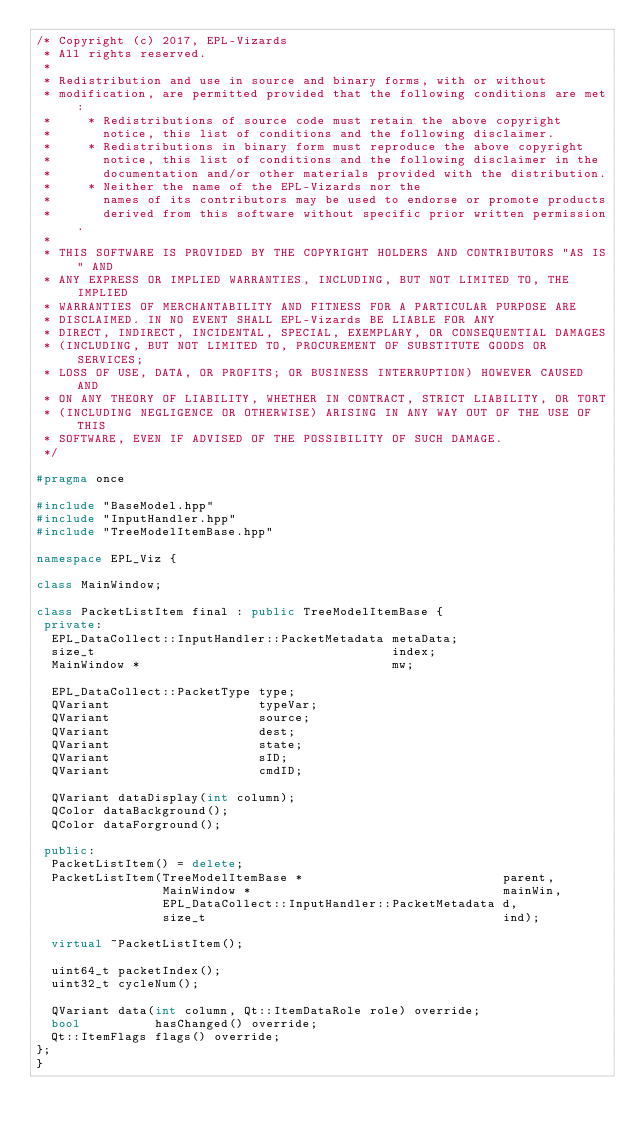Convert code to text. <code><loc_0><loc_0><loc_500><loc_500><_C++_>/* Copyright (c) 2017, EPL-Vizards
 * All rights reserved.
 *
 * Redistribution and use in source and binary forms, with or without
 * modification, are permitted provided that the following conditions are met:
 *     * Redistributions of source code must retain the above copyright
 *       notice, this list of conditions and the following disclaimer.
 *     * Redistributions in binary form must reproduce the above copyright
 *       notice, this list of conditions and the following disclaimer in the
 *       documentation and/or other materials provided with the distribution.
 *     * Neither the name of the EPL-Vizards nor the
 *       names of its contributors may be used to endorse or promote products
 *       derived from this software without specific prior written permission.
 *
 * THIS SOFTWARE IS PROVIDED BY THE COPYRIGHT HOLDERS AND CONTRIBUTORS "AS IS" AND
 * ANY EXPRESS OR IMPLIED WARRANTIES, INCLUDING, BUT NOT LIMITED TO, THE IMPLIED
 * WARRANTIES OF MERCHANTABILITY AND FITNESS FOR A PARTICULAR PURPOSE ARE
 * DISCLAIMED. IN NO EVENT SHALL EPL-Vizards BE LIABLE FOR ANY
 * DIRECT, INDIRECT, INCIDENTAL, SPECIAL, EXEMPLARY, OR CONSEQUENTIAL DAMAGES
 * (INCLUDING, BUT NOT LIMITED TO, PROCUREMENT OF SUBSTITUTE GOODS OR SERVICES;
 * LOSS OF USE, DATA, OR PROFITS; OR BUSINESS INTERRUPTION) HOWEVER CAUSED AND
 * ON ANY THEORY OF LIABILITY, WHETHER IN CONTRACT, STRICT LIABILITY, OR TORT
 * (INCLUDING NEGLIGENCE OR OTHERWISE) ARISING IN ANY WAY OUT OF THE USE OF THIS
 * SOFTWARE, EVEN IF ADVISED OF THE POSSIBILITY OF SUCH DAMAGE.
 */

#pragma once

#include "BaseModel.hpp"
#include "InputHandler.hpp"
#include "TreeModelItemBase.hpp"

namespace EPL_Viz {

class MainWindow;

class PacketListItem final : public TreeModelItemBase {
 private:
  EPL_DataCollect::InputHandler::PacketMetadata metaData;
  size_t                                        index;
  MainWindow *                                  mw;

  EPL_DataCollect::PacketType type;
  QVariant                    typeVar;
  QVariant                    source;
  QVariant                    dest;
  QVariant                    state;
  QVariant                    sID;
  QVariant                    cmdID;

  QVariant dataDisplay(int column);
  QColor dataBackground();
  QColor dataForground();

 public:
  PacketListItem() = delete;
  PacketListItem(TreeModelItemBase *                           parent,
                 MainWindow *                                  mainWin,
                 EPL_DataCollect::InputHandler::PacketMetadata d,
                 size_t                                        ind);

  virtual ~PacketListItem();

  uint64_t packetIndex();
  uint32_t cycleNum();

  QVariant data(int column, Qt::ItemDataRole role) override;
  bool          hasChanged() override;
  Qt::ItemFlags flags() override;
};
}
</code> 